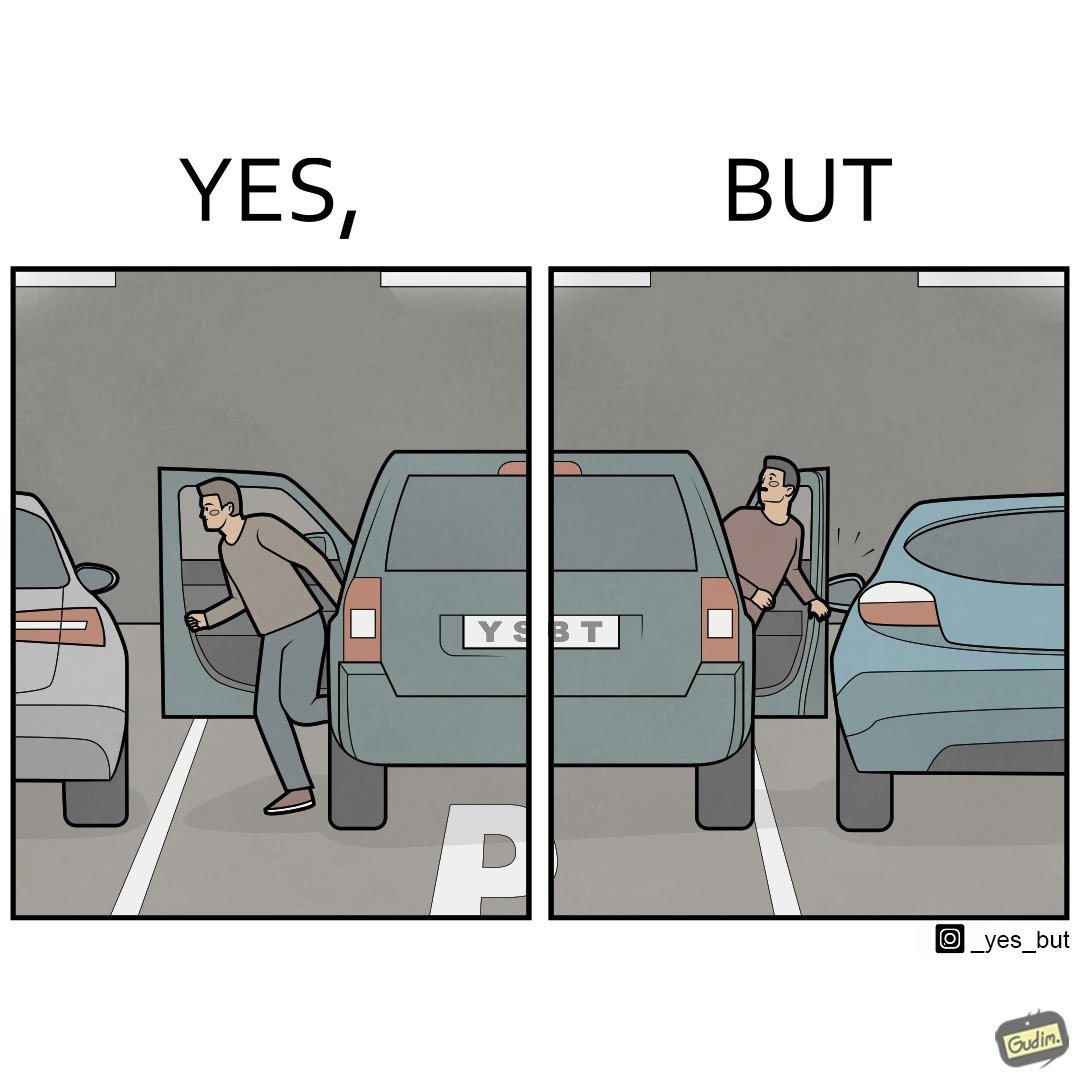Is there satirical content in this image? Yes, this image is satirical. 